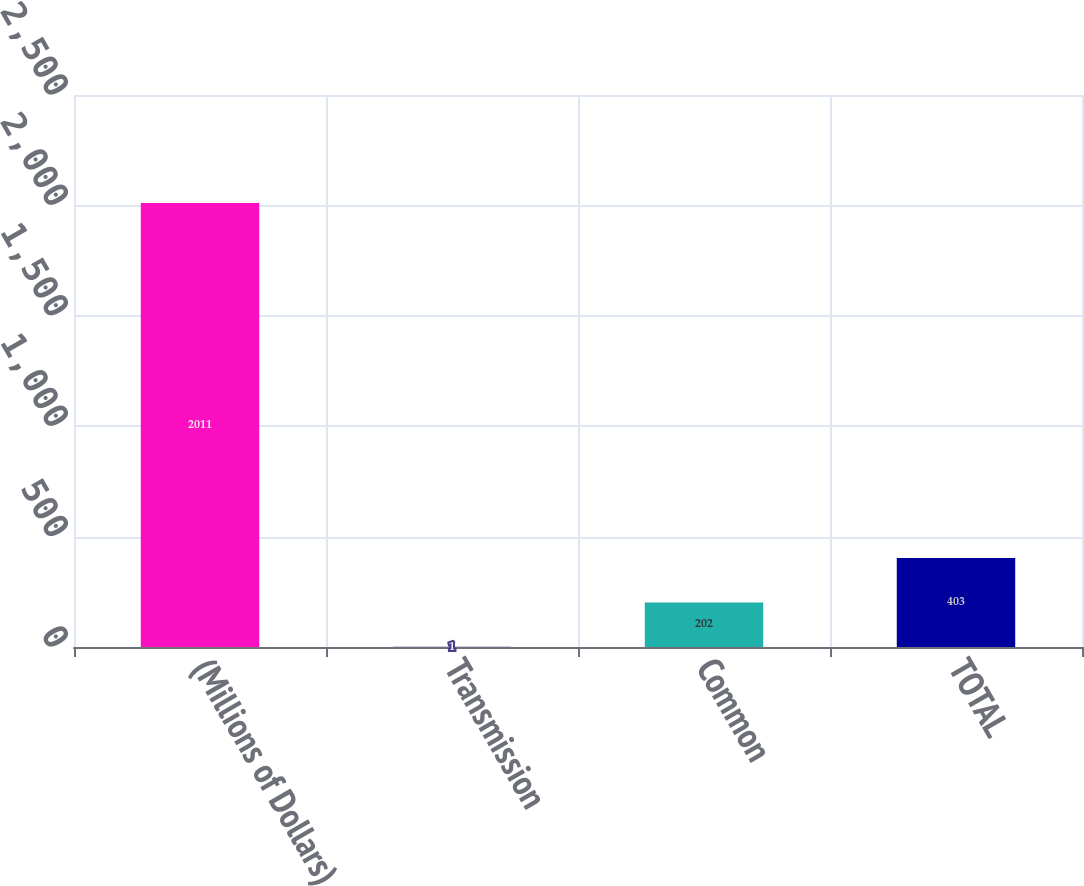Convert chart. <chart><loc_0><loc_0><loc_500><loc_500><bar_chart><fcel>(Millions of Dollars)<fcel>Transmission<fcel>Common<fcel>TOTAL<nl><fcel>2011<fcel>1<fcel>202<fcel>403<nl></chart> 